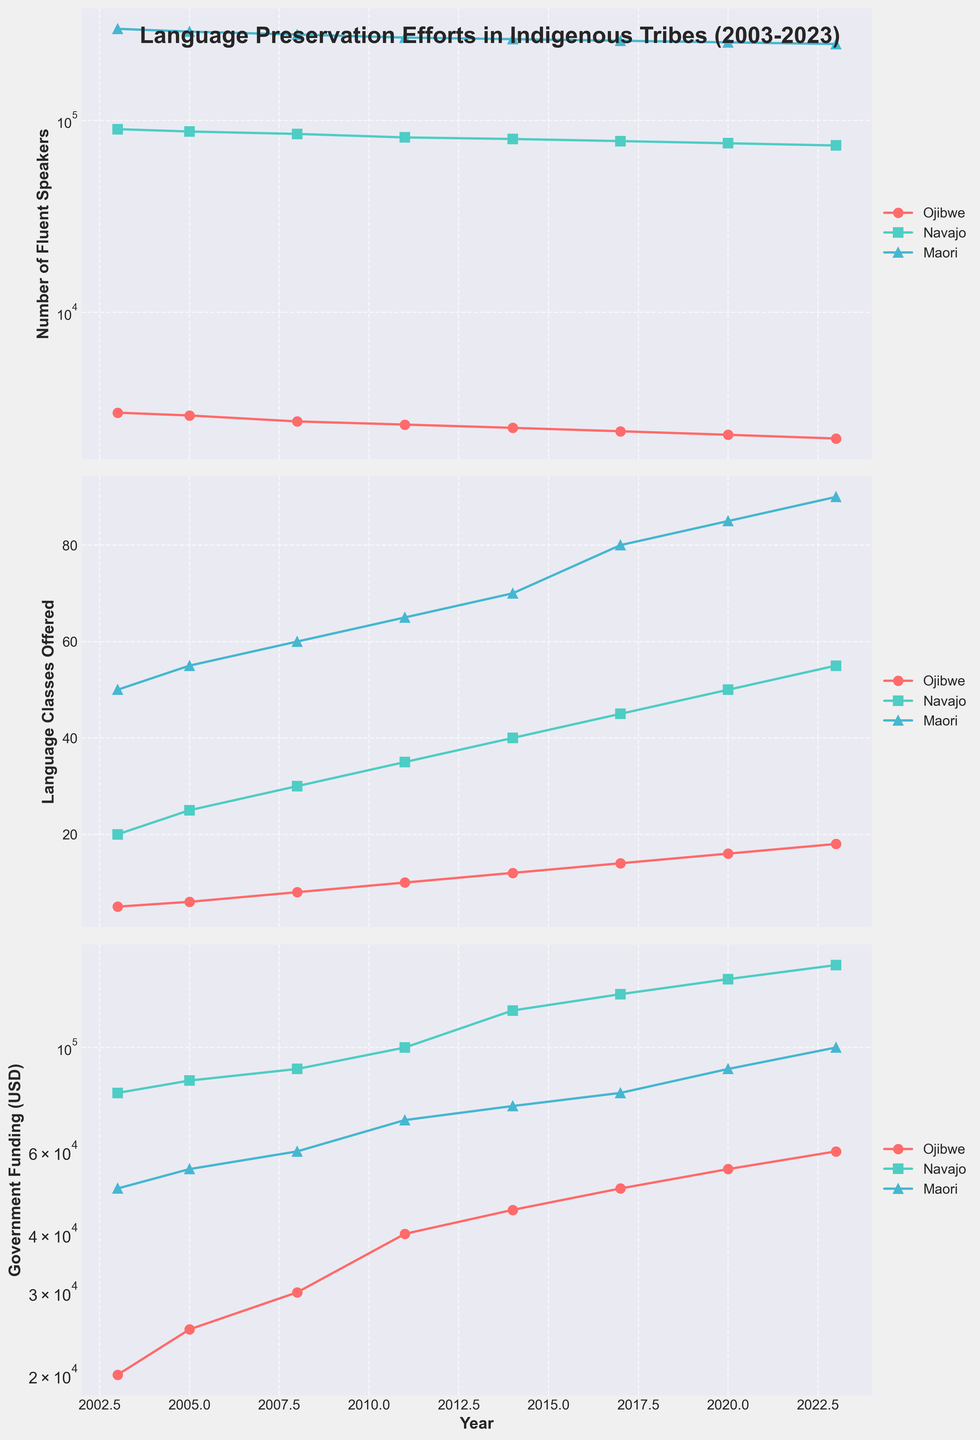What's the title of the figure? The title is generally located at the top of the figure, and it gives an overview of what the plot is about. Here, the title states: 'Language Preservation Efforts in Indigenous Tribes (2003-2023)'.
Answer: Language Preservation Efforts in Indigenous Tribes (2003-2023) How many tribes are represented in the figure? By examining the legend or the plot series, we can see that three tribes are plotted. These tribes are Ojibwe, Navajo, and Maori.
Answer: Three Which tribe received the highest government funding in 2023? By looking at the bottom plot, which represents government funding, we can see that the Maori tribe received the highest amount of government funding in 2023.
Answer: Maori Is the number of Ojibwe fluent speakers increasing or decreasing over time? By observing the top plot which shows the number of fluent speakers, we can see that the number of Ojibwe fluent speakers has been decreasing over time from 2003 to 2023.
Answer: Decreasing How many language classes were offered by the Navajo tribe in 2008? Looking at the middle plot, which shows language classes offered, and finding the data point for the year 2008 associated with the Navajo tribe, we see they offered 30 language classes.
Answer: 30 What is the trend in government funding for the Maori tribe over the last 20 years? By examining the trend line for the Maori tribe in the bottom plot, it can be detected that government funding has been steadily increasing from 2003 to 2023.
Answer: Increasing Which tribe showed a consistent increase in language classes offered every three years? By observing the middle plot and evaluating the trend lines for each tribe, we see that the Navajo tribe consistently increased the number of language classes offered every three years.
Answer: Navajo Compare the number of fluent speakers between the Ojibwe and Maori tribes in 2023. By comparing the data points for 2023 in the top plot, we can see that the Maori tribe has 250,000 fluent speakers, whereas the Ojibwe tribe has 2,200 fluent speakers.
Answer: Maori has more How did government funding for the Ojibwe tribe change between 2003 and 2023? By evaluating the government funding plot for Ojibwe, it can be observed that funding increased from $20,000 in 2003 to $60,000 in 2023.
Answer: Increased Which tribe had the largest number of fluent speakers in 2003? By checking the data points for 2003 in the top plot, we find that the Maori tribe had the largest number of fluent speakers, with 300,000 individuals.
Answer: Maori 